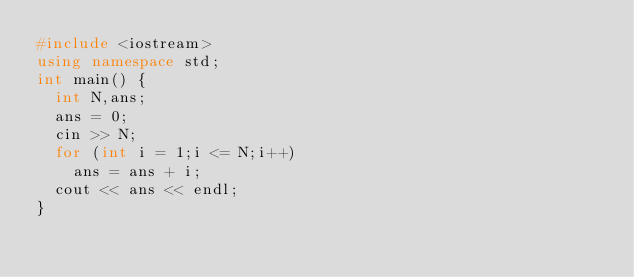<code> <loc_0><loc_0><loc_500><loc_500><_C++_>#include <iostream>
using namespace std;
int main() {
	int N,ans;
	ans = 0;
	cin >> N;
	for (int i = 1;i <= N;i++)
		ans = ans + i;
	cout << ans << endl;
}</code> 